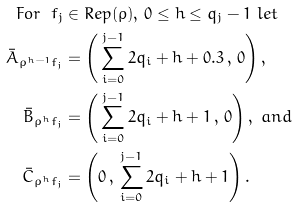Convert formula to latex. <formula><loc_0><loc_0><loc_500><loc_500>F o r \ f _ { j } & \in R e p ( \rho ) , \, 0 \leq h \leq q _ { j } - 1 \ l e t \\ \bar { A } _ { \rho ^ { h - 1 } f _ { j } } & = \left ( \, \sum _ { i = 0 } ^ { j - 1 } 2 q _ { i } + h + 0 . 3 \, , \, 0 \right ) , \\ \bar { B } _ { \rho ^ { h } f _ { j } } & = \left ( \, \sum _ { i = 0 } ^ { j - 1 } 2 q _ { i } + h + 1 \, , \, 0 \right ) , \ a n d \\ \bar { C } _ { \rho ^ { h } f _ { j } } & = \left ( 0 \, , \, \sum _ { i = 0 } ^ { j - 1 } 2 q _ { i } + h + 1 \right ) .</formula> 